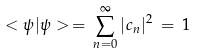<formula> <loc_0><loc_0><loc_500><loc_500>< \psi | \psi > \, = \, \sum _ { n = 0 } ^ { \infty } | c _ { n } | ^ { 2 } \, = \, 1</formula> 